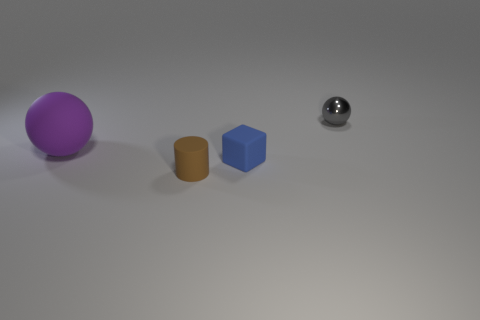Add 1 big yellow things. How many objects exist? 5 Subtract all cylinders. How many objects are left? 3 Subtract 1 gray balls. How many objects are left? 3 Subtract all cyan objects. Subtract all blue things. How many objects are left? 3 Add 2 blue things. How many blue things are left? 3 Add 4 red cubes. How many red cubes exist? 4 